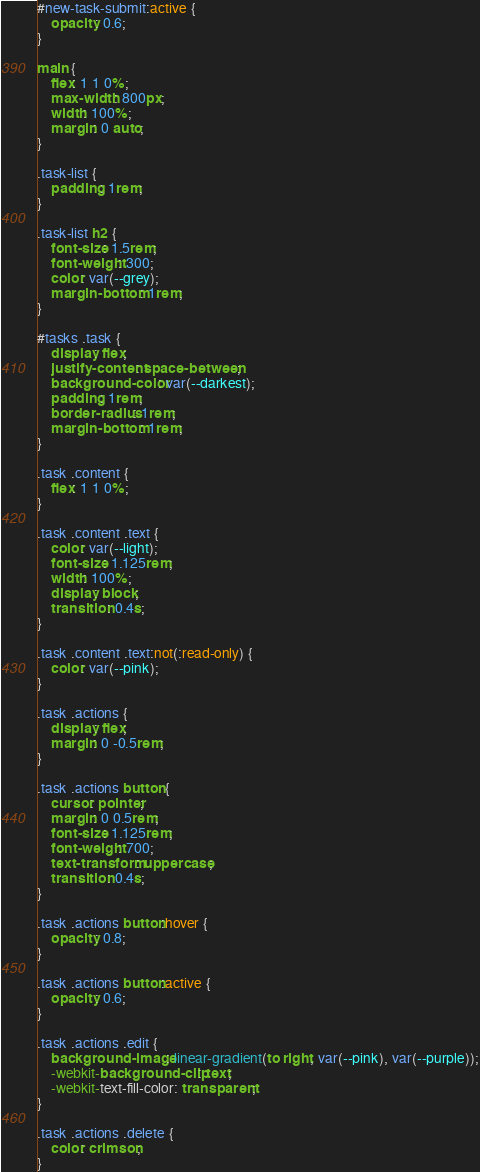<code> <loc_0><loc_0><loc_500><loc_500><_CSS_>#new-task-submit:active {
	opacity: 0.6;
}

main {
	flex: 1 1 0%;
	max-width: 800px;
	width: 100%;
	margin: 0 auto;
}

.task-list {
	padding: 1rem;
}

.task-list h2 {
	font-size: 1.5rem;
	font-weight: 300;
	color: var(--grey);
	margin-bottom: 1rem;
}

#tasks .task {
	display: flex;
	justify-content: space-between;
	background-color: var(--darkest);
	padding: 1rem;
	border-radius: 1rem;
	margin-bottom: 1rem;
}

.task .content {
	flex: 1 1 0%;
}

.task .content .text {
	color: var(--light);
	font-size: 1.125rem;
	width: 100%;
	display: block;
	transition: 0.4s;
}

.task .content .text:not(:read-only) {
	color: var(--pink);
}

.task .actions {
	display: flex;
	margin: 0 -0.5rem;
}

.task .actions button {
	cursor: pointer;
	margin: 0 0.5rem;
	font-size: 1.125rem;
	font-weight: 700;
	text-transform: uppercase;
	transition: 0.4s;
}

.task .actions button:hover {
	opacity: 0.8;
}

.task .actions button:active {
	opacity: 0.6;
}

.task .actions .edit {
	background-image: linear-gradient(to right, var(--pink), var(--purple));
	-webkit-background-clip: text;
	-webkit-text-fill-color: transparent;
}

.task .actions .delete {
	color: crimson;
}</code> 